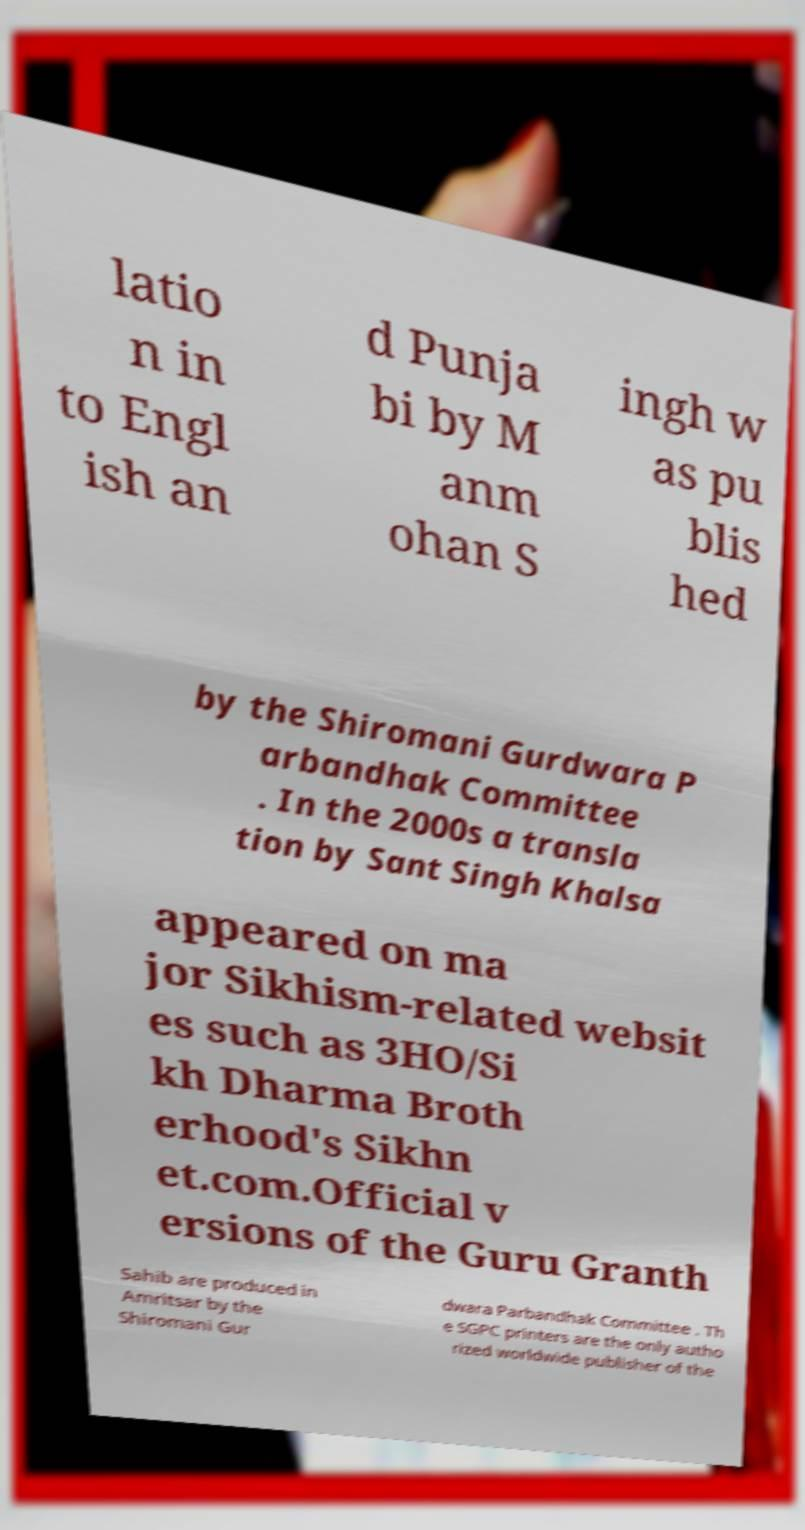Please read and relay the text visible in this image. What does it say? latio n in to Engl ish an d Punja bi by M anm ohan S ingh w as pu blis hed by the Shiromani Gurdwara P arbandhak Committee . In the 2000s a transla tion by Sant Singh Khalsa appeared on ma jor Sikhism-related websit es such as 3HO/Si kh Dharma Broth erhood's Sikhn et.com.Official v ersions of the Guru Granth Sahib are produced in Amritsar by the Shiromani Gur dwara Parbandhak Committee . Th e SGPC printers are the only autho rized worldwide publisher of the 